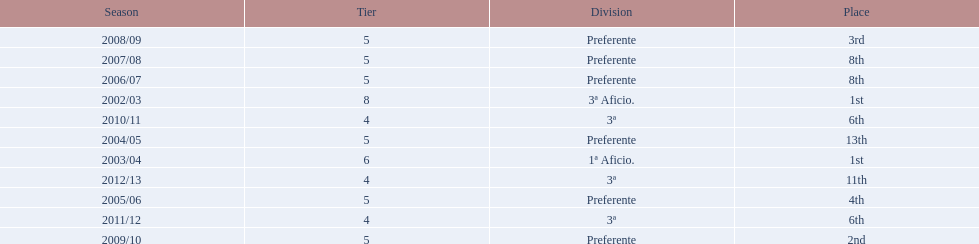Which division has the largest number of ranks? Preferente. 